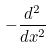<formula> <loc_0><loc_0><loc_500><loc_500>- \frac { d ^ { 2 } } { d x ^ { 2 } }</formula> 